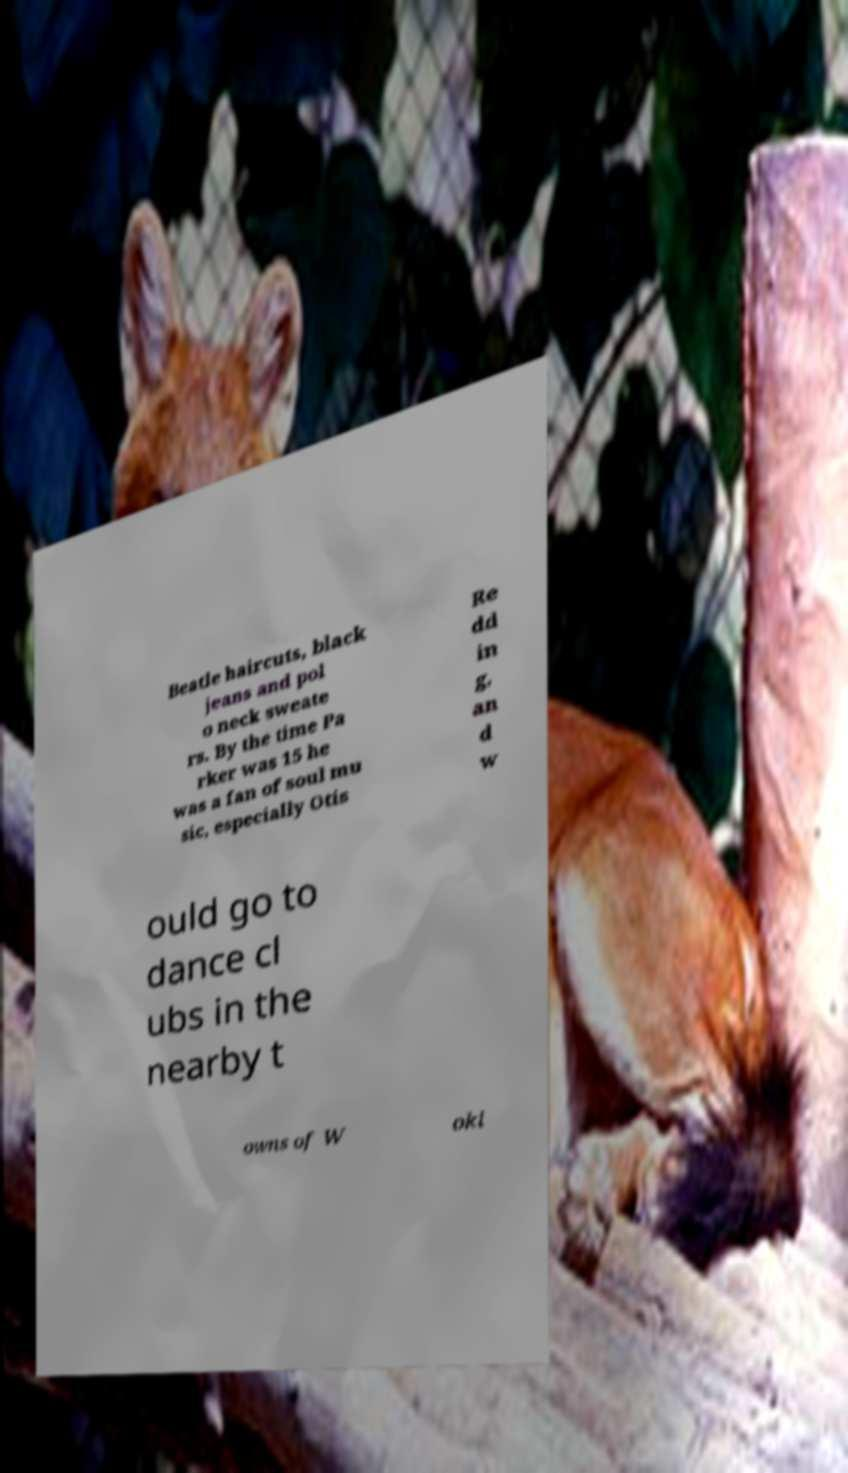What messages or text are displayed in this image? I need them in a readable, typed format. Beatle haircuts, black jeans and pol o neck sweate rs. By the time Pa rker was 15 he was a fan of soul mu sic, especially Otis Re dd in g, an d w ould go to dance cl ubs in the nearby t owns of W oki 